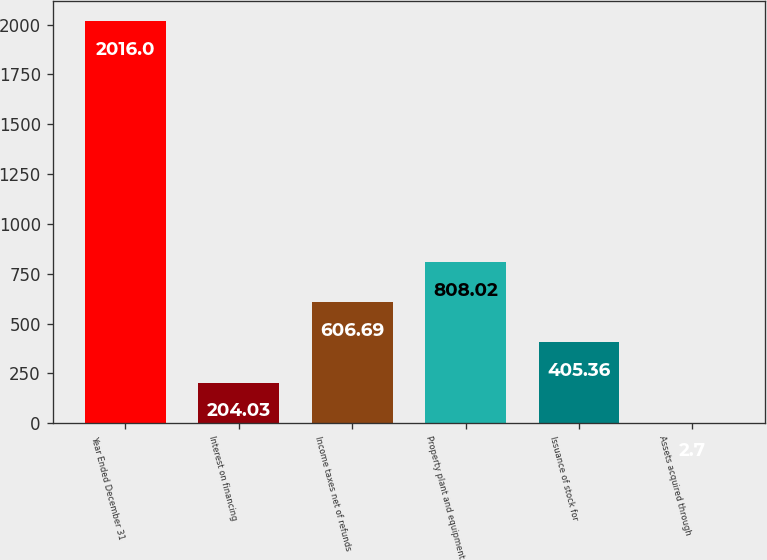<chart> <loc_0><loc_0><loc_500><loc_500><bar_chart><fcel>Year Ended December 31<fcel>Interest on financing<fcel>Income taxes net of refunds<fcel>Property plant and equipment<fcel>Issuance of stock for<fcel>Assets acquired through<nl><fcel>2016<fcel>204.03<fcel>606.69<fcel>808.02<fcel>405.36<fcel>2.7<nl></chart> 